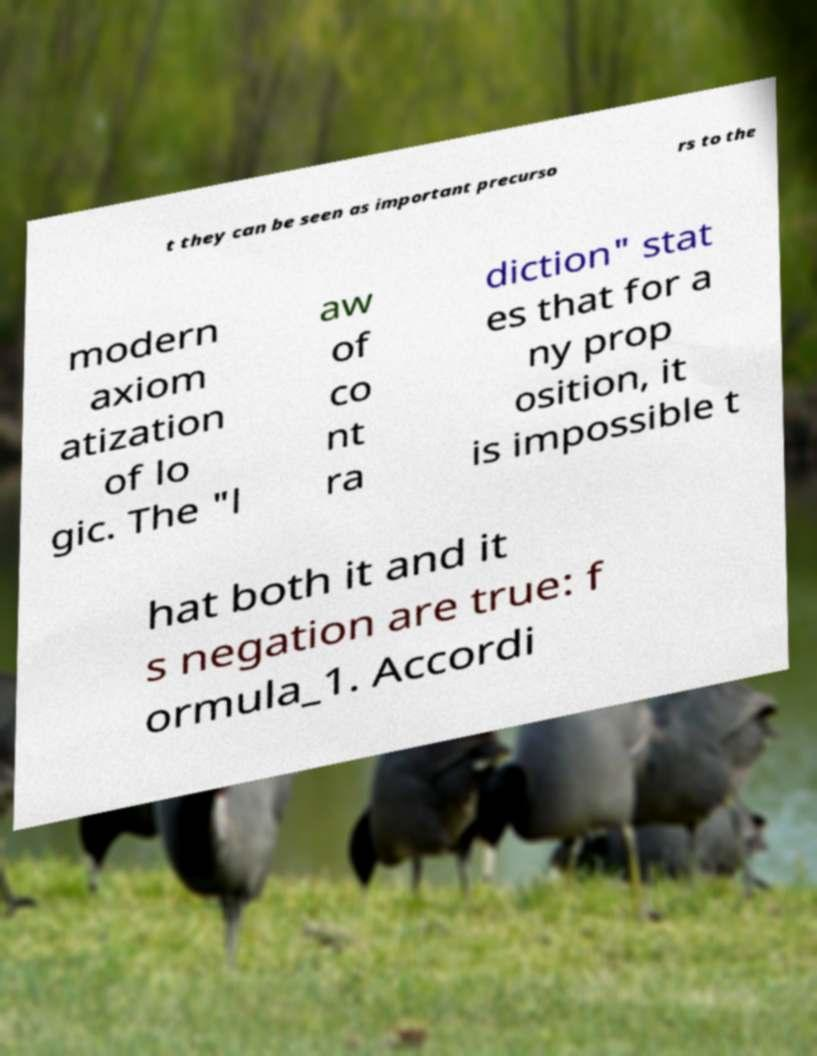Please identify and transcribe the text found in this image. t they can be seen as important precurso rs to the modern axiom atization of lo gic. The "l aw of co nt ra diction" stat es that for a ny prop osition, it is impossible t hat both it and it s negation are true: f ormula_1. Accordi 